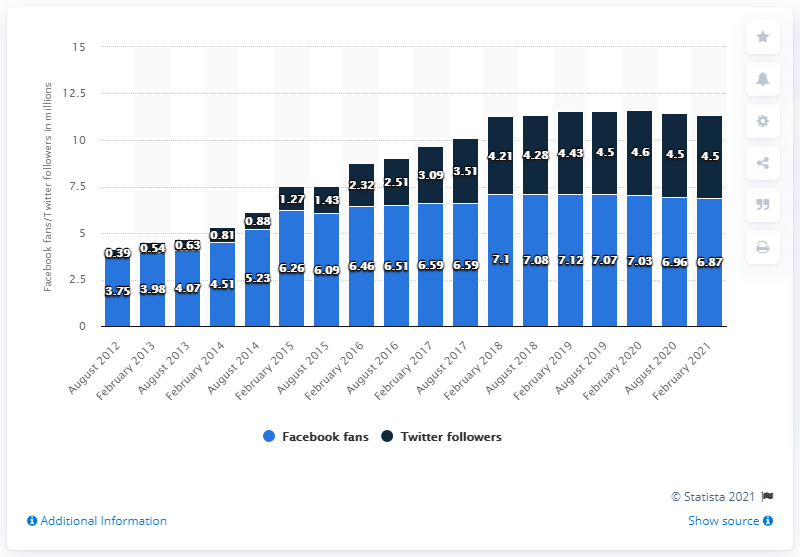List a handful of essential elements in this visual. As of February 2021, the New England Patriots football team had 6.87 million Facebook followers. 